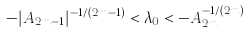Convert formula to latex. <formula><loc_0><loc_0><loc_500><loc_500>- | A _ { 2 m - 1 } | ^ { - 1 / ( 2 m - 1 ) } < \lambda _ { 0 } < - A _ { 2 m } ^ { - 1 / ( 2 m ) }</formula> 